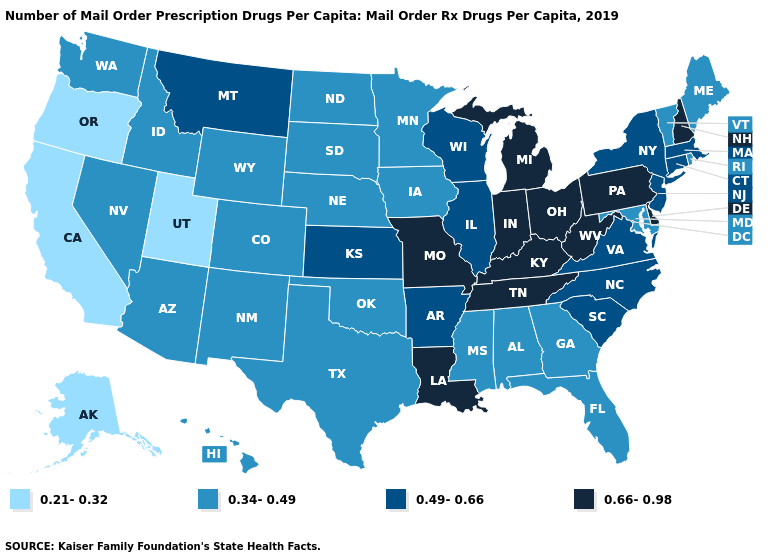What is the value of Louisiana?
Quick response, please. 0.66-0.98. Does Minnesota have the lowest value in the USA?
Short answer required. No. Name the states that have a value in the range 0.66-0.98?
Be succinct. Delaware, Indiana, Kentucky, Louisiana, Michigan, Missouri, New Hampshire, Ohio, Pennsylvania, Tennessee, West Virginia. Which states have the lowest value in the USA?
Be succinct. Alaska, California, Oregon, Utah. Does California have the lowest value in the West?
Quick response, please. Yes. Does Alabama have the same value as Texas?
Write a very short answer. Yes. Which states hav the highest value in the Northeast?
Give a very brief answer. New Hampshire, Pennsylvania. Name the states that have a value in the range 0.21-0.32?
Quick response, please. Alaska, California, Oregon, Utah. Does Tennessee have the highest value in the South?
Give a very brief answer. Yes. Name the states that have a value in the range 0.66-0.98?
Write a very short answer. Delaware, Indiana, Kentucky, Louisiana, Michigan, Missouri, New Hampshire, Ohio, Pennsylvania, Tennessee, West Virginia. What is the value of Massachusetts?
Concise answer only. 0.49-0.66. What is the lowest value in the USA?
Keep it brief. 0.21-0.32. Among the states that border Mississippi , does Alabama have the lowest value?
Keep it brief. Yes. Does the map have missing data?
Give a very brief answer. No. 